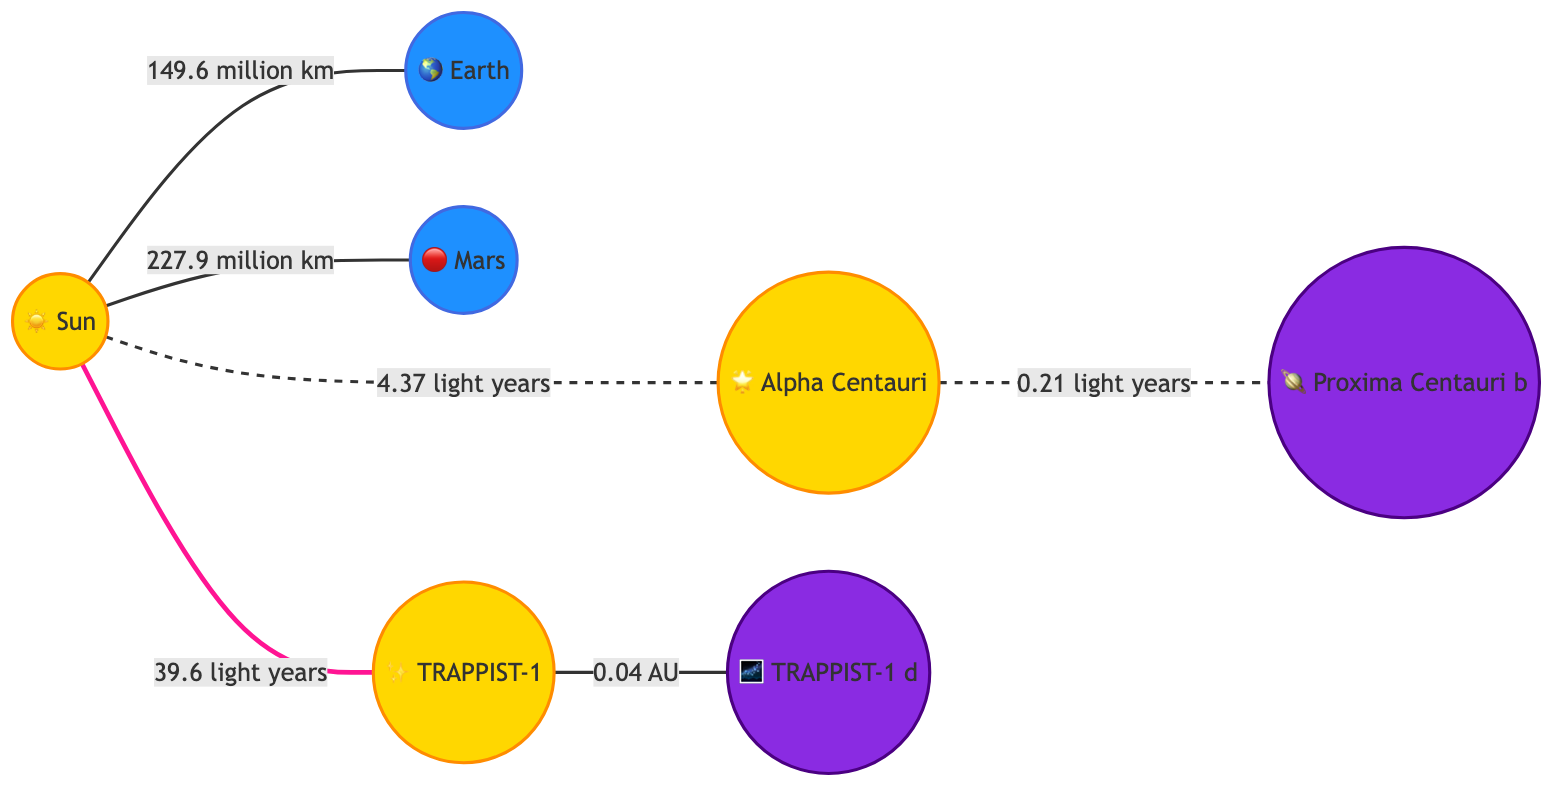What is the distance between the Sun and Earth? The diagram shows a direct edge from the Sun to Earth labeled with the distance. The label states "149.6 million km." Thus, reading directly from the diagram gives the value.
Answer: 149.6 million km What planet is located at a distance of 227.9 million km from the Sun? The edge connecting the Sun and Mars is labeled "227.9 million km," indicating this measurement is specifically referring to Mars. Therefore, identifying the nodes points directly to the answer.
Answer: Mars What is the distance from Alpha Centauri to Proxima Centauri b? Looking at the edge between Alpha Centauri and Proxima Centauri b, the label indicates the distance as "0.21 light years." Thus, it is a straightforward reading off the diagram.
Answer: 0.21 light years Which objects in the diagram are categorized as exoplanets? The nodes representing Proxima Centauri b and TRAPPIST-1 d are both classified with the style indicating they are exoplanets. A direct visual identification matches them with their corresponding class definition in the diagram.
Answer: Proxima Centauri b, TRAPPIST-1 d How many light years separate the Sun from TRAPPIST-1? From the diagram, a direct edge shows the distance from the Sun to TRAPPIST-1 labeled "39.6 light years." Therefore, counting the labels gives a single answer directly from the edge.
Answer: 39.6 light years What is the relationship between TRAPPIST-1 and TRAPPIST-1 d? The edge between TRAPPIST-1 and TRAPPIST-1 d shows a direct connection with a label stating "0.04 AU," indicating the proximity of these two objects. Hence, the relationship is defined by this connection.
Answer: 0.04 AU Which star is closest to Earth according to the diagram? When analyzing the distances provided, Alpha Centauri is shown at a distance of "4.37 light years" from the Sun, making it the closest star as per the diagram compared to any other listed.
Answer: Alpha Centauri What color represents the planets in this diagram? The class definition for planets specifies a fill color of blue, with the edges styled accordingly. Observing the key visual classification in the diagram confirms this.
Answer: Blue 